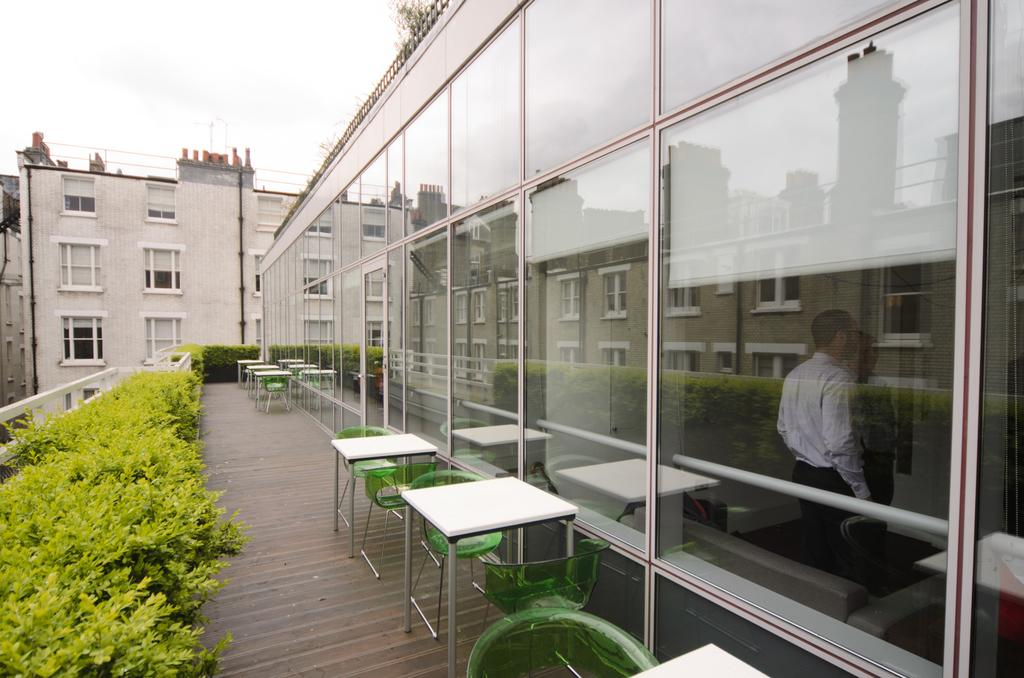What type of structure is visible in the image? There is a glass room in the image. What furniture is located outside the glass room? There are tables and chairs outside the glass room. What can be seen between the tables and chairs? There are plants in front of the tables and chairs. What does the uncle do to the glass room in the image? There is no uncle present in the image, and therefore no action can be attributed to him. 